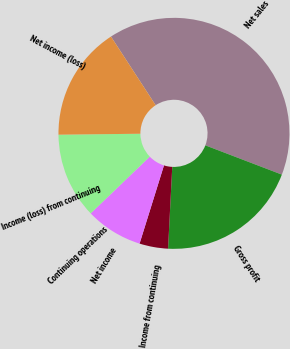Convert chart to OTSL. <chart><loc_0><loc_0><loc_500><loc_500><pie_chart><fcel>Net sales<fcel>Gross profit<fcel>Income from continuing<fcel>Net income<fcel>Continuing operations<fcel>Income (loss) from continuing<fcel>Net income (loss)<nl><fcel>40.0%<fcel>20.0%<fcel>4.0%<fcel>8.0%<fcel>0.0%<fcel>12.0%<fcel>16.0%<nl></chart> 